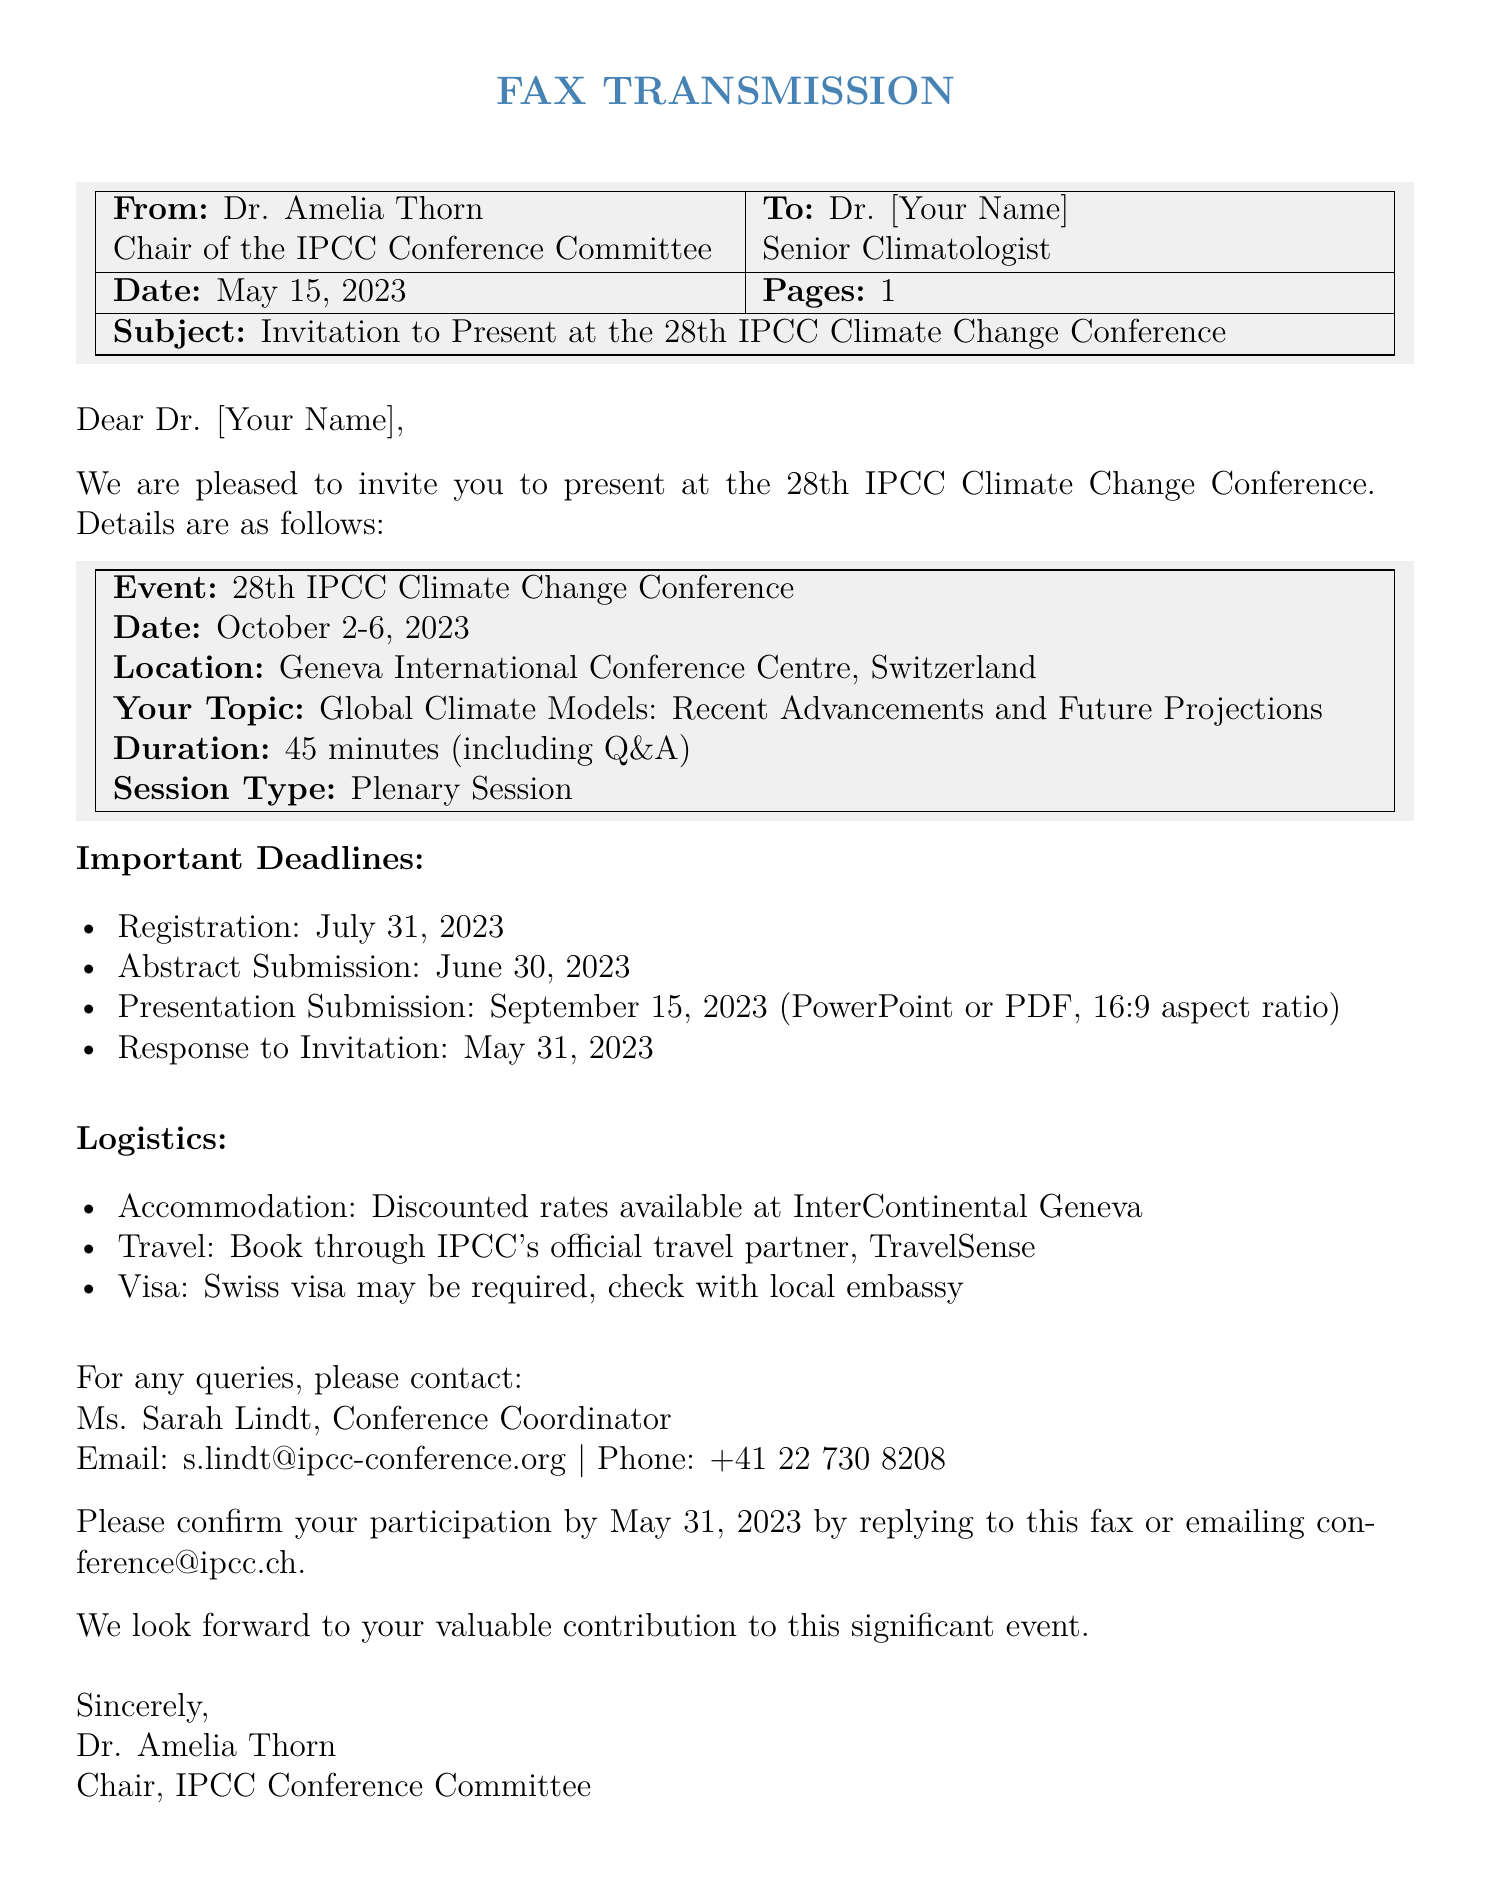What is the date of the conference? The date of the conference is specified in the document, which mentions October 2-6, 2023.
Answer: October 2-6, 2023 Who is the sender of the fax? The document states that the fax is from Dr. Amelia Thorn.
Answer: Dr. Amelia Thorn What is the topic you are invited to present? The topic of the presentation is listed in the document as "Global Climate Models: Recent Advancements and Future Projections."
Answer: Global Climate Models: Recent Advancements and Future Projections What is the response deadline for the invitation? The document specifies the response to the invitation must be confirmed by May 31, 2023.
Answer: May 31, 2023 What type of session will the presentation be? The document mentions that the session type is a Plenary Session.
Answer: Plenary Session What accommodation is mentioned for the conference? The document states that discounted rates are available at InterContinental Geneva.
Answer: InterContinental Geneva When is the abstract submission deadline? The abstract submission deadline is explicitly mentioned as June 30, 2023.
Answer: June 30, 2023 What is required if a visa is needed? The document indicates to check with the local embassy regarding the Swiss visa.
Answer: Check with local embassy What is the duration of the presentation? The document provides the duration of the presentation, which is 45 minutes.
Answer: 45 minutes 